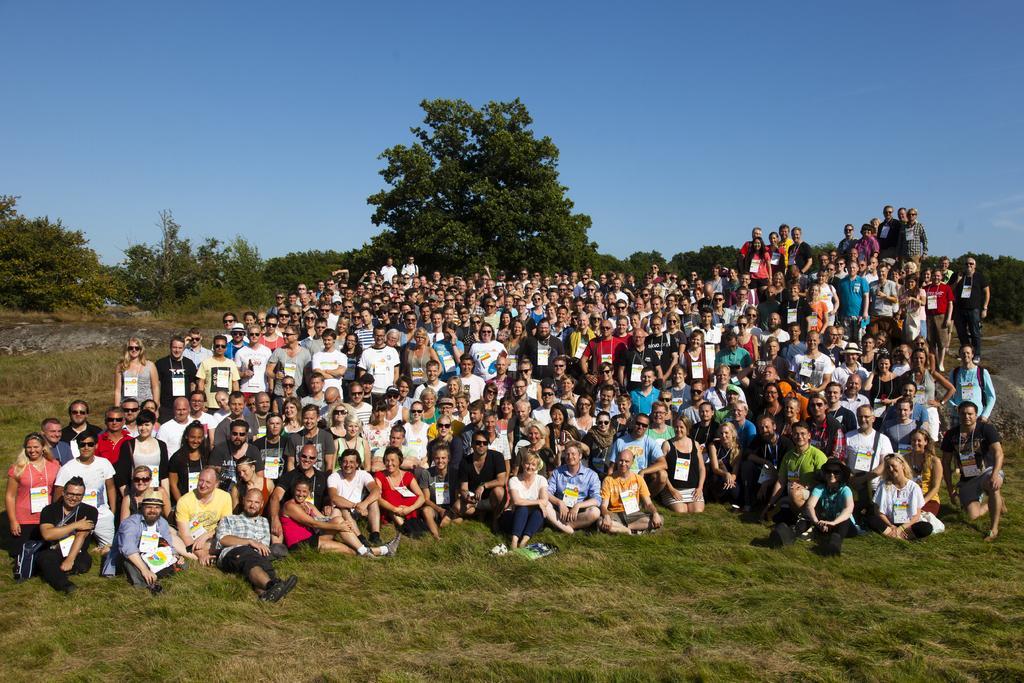In one or two sentences, can you explain what this image depicts? In this image, I can see a group of people standing and sitting. This is the grass. These are the trees with branches and leaves. Here is the sky. 